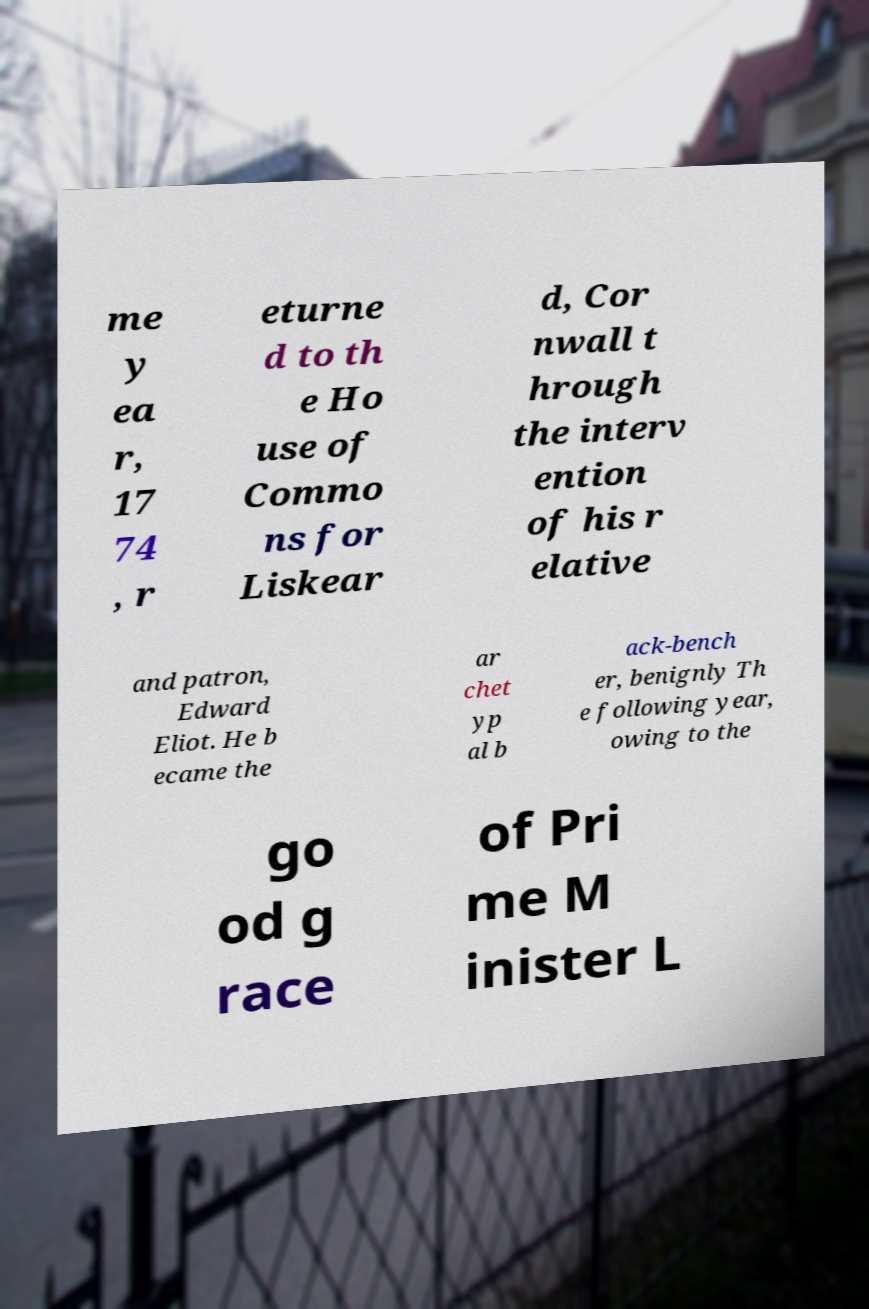There's text embedded in this image that I need extracted. Can you transcribe it verbatim? me y ea r, 17 74 , r eturne d to th e Ho use of Commo ns for Liskear d, Cor nwall t hrough the interv ention of his r elative and patron, Edward Eliot. He b ecame the ar chet yp al b ack-bench er, benignly Th e following year, owing to the go od g race of Pri me M inister L 